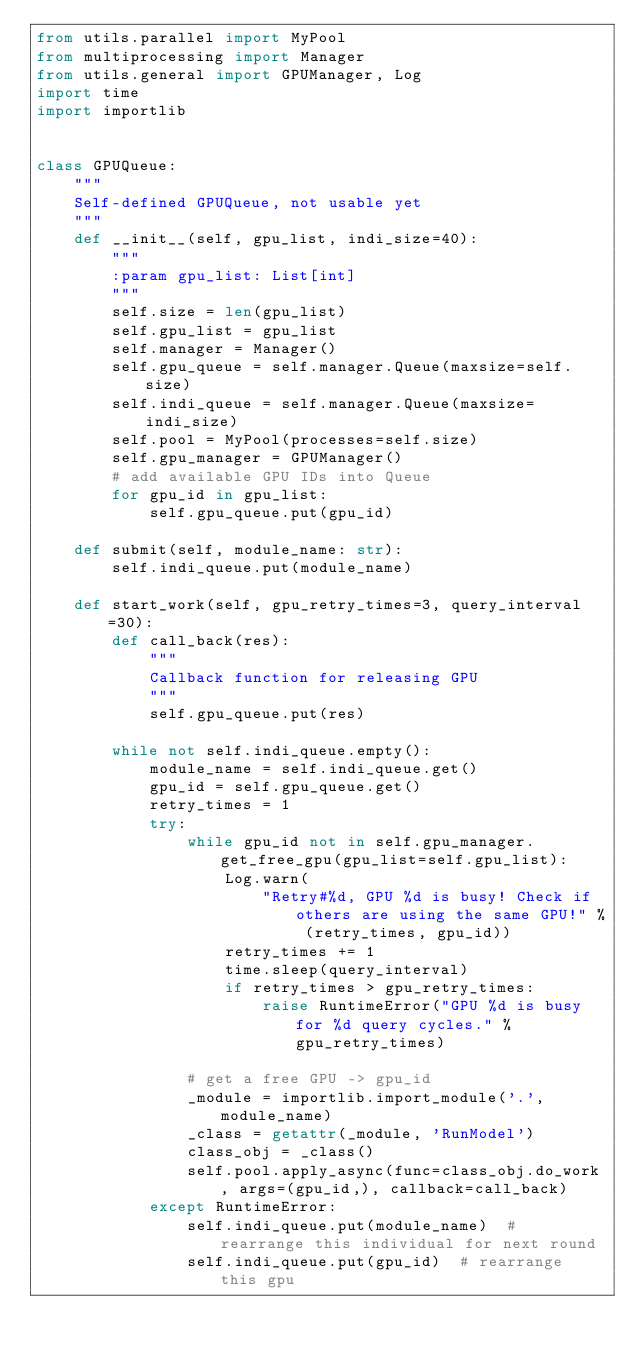Convert code to text. <code><loc_0><loc_0><loc_500><loc_500><_Python_>from utils.parallel import MyPool
from multiprocessing import Manager
from utils.general import GPUManager, Log
import time
import importlib


class GPUQueue:
    """
    Self-defined GPUQueue, not usable yet
    """
    def __init__(self, gpu_list, indi_size=40):
        """
        :param gpu_list: List[int]
        """
        self.size = len(gpu_list)
        self.gpu_list = gpu_list
        self.manager = Manager()
        self.gpu_queue = self.manager.Queue(maxsize=self.size)
        self.indi_queue = self.manager.Queue(maxsize=indi_size)
        self.pool = MyPool(processes=self.size)
        self.gpu_manager = GPUManager()
        # add available GPU IDs into Queue
        for gpu_id in gpu_list:
            self.gpu_queue.put(gpu_id)

    def submit(self, module_name: str):
        self.indi_queue.put(module_name)

    def start_work(self, gpu_retry_times=3, query_interval=30):
        def call_back(res):
            """
            Callback function for releasing GPU
            """
            self.gpu_queue.put(res)

        while not self.indi_queue.empty():
            module_name = self.indi_queue.get()
            gpu_id = self.gpu_queue.get()
            retry_times = 1
            try:
                while gpu_id not in self.gpu_manager.get_free_gpu(gpu_list=self.gpu_list):
                    Log.warn(
                        "Retry#%d, GPU %d is busy! Check if others are using the same GPU!" % (retry_times, gpu_id))
                    retry_times += 1
                    time.sleep(query_interval)
                    if retry_times > gpu_retry_times:
                        raise RuntimeError("GPU %d is busy for %d query cycles." % gpu_retry_times)

                # get a free GPU -> gpu_id
                _module = importlib.import_module('.', module_name)
                _class = getattr(_module, 'RunModel')
                class_obj = _class()
                self.pool.apply_async(func=class_obj.do_work, args=(gpu_id,), callback=call_back)
            except RuntimeError:
                self.indi_queue.put(module_name)  # rearrange this individual for next round
                self.indi_queue.put(gpu_id)  # rearrange this gpu
</code> 